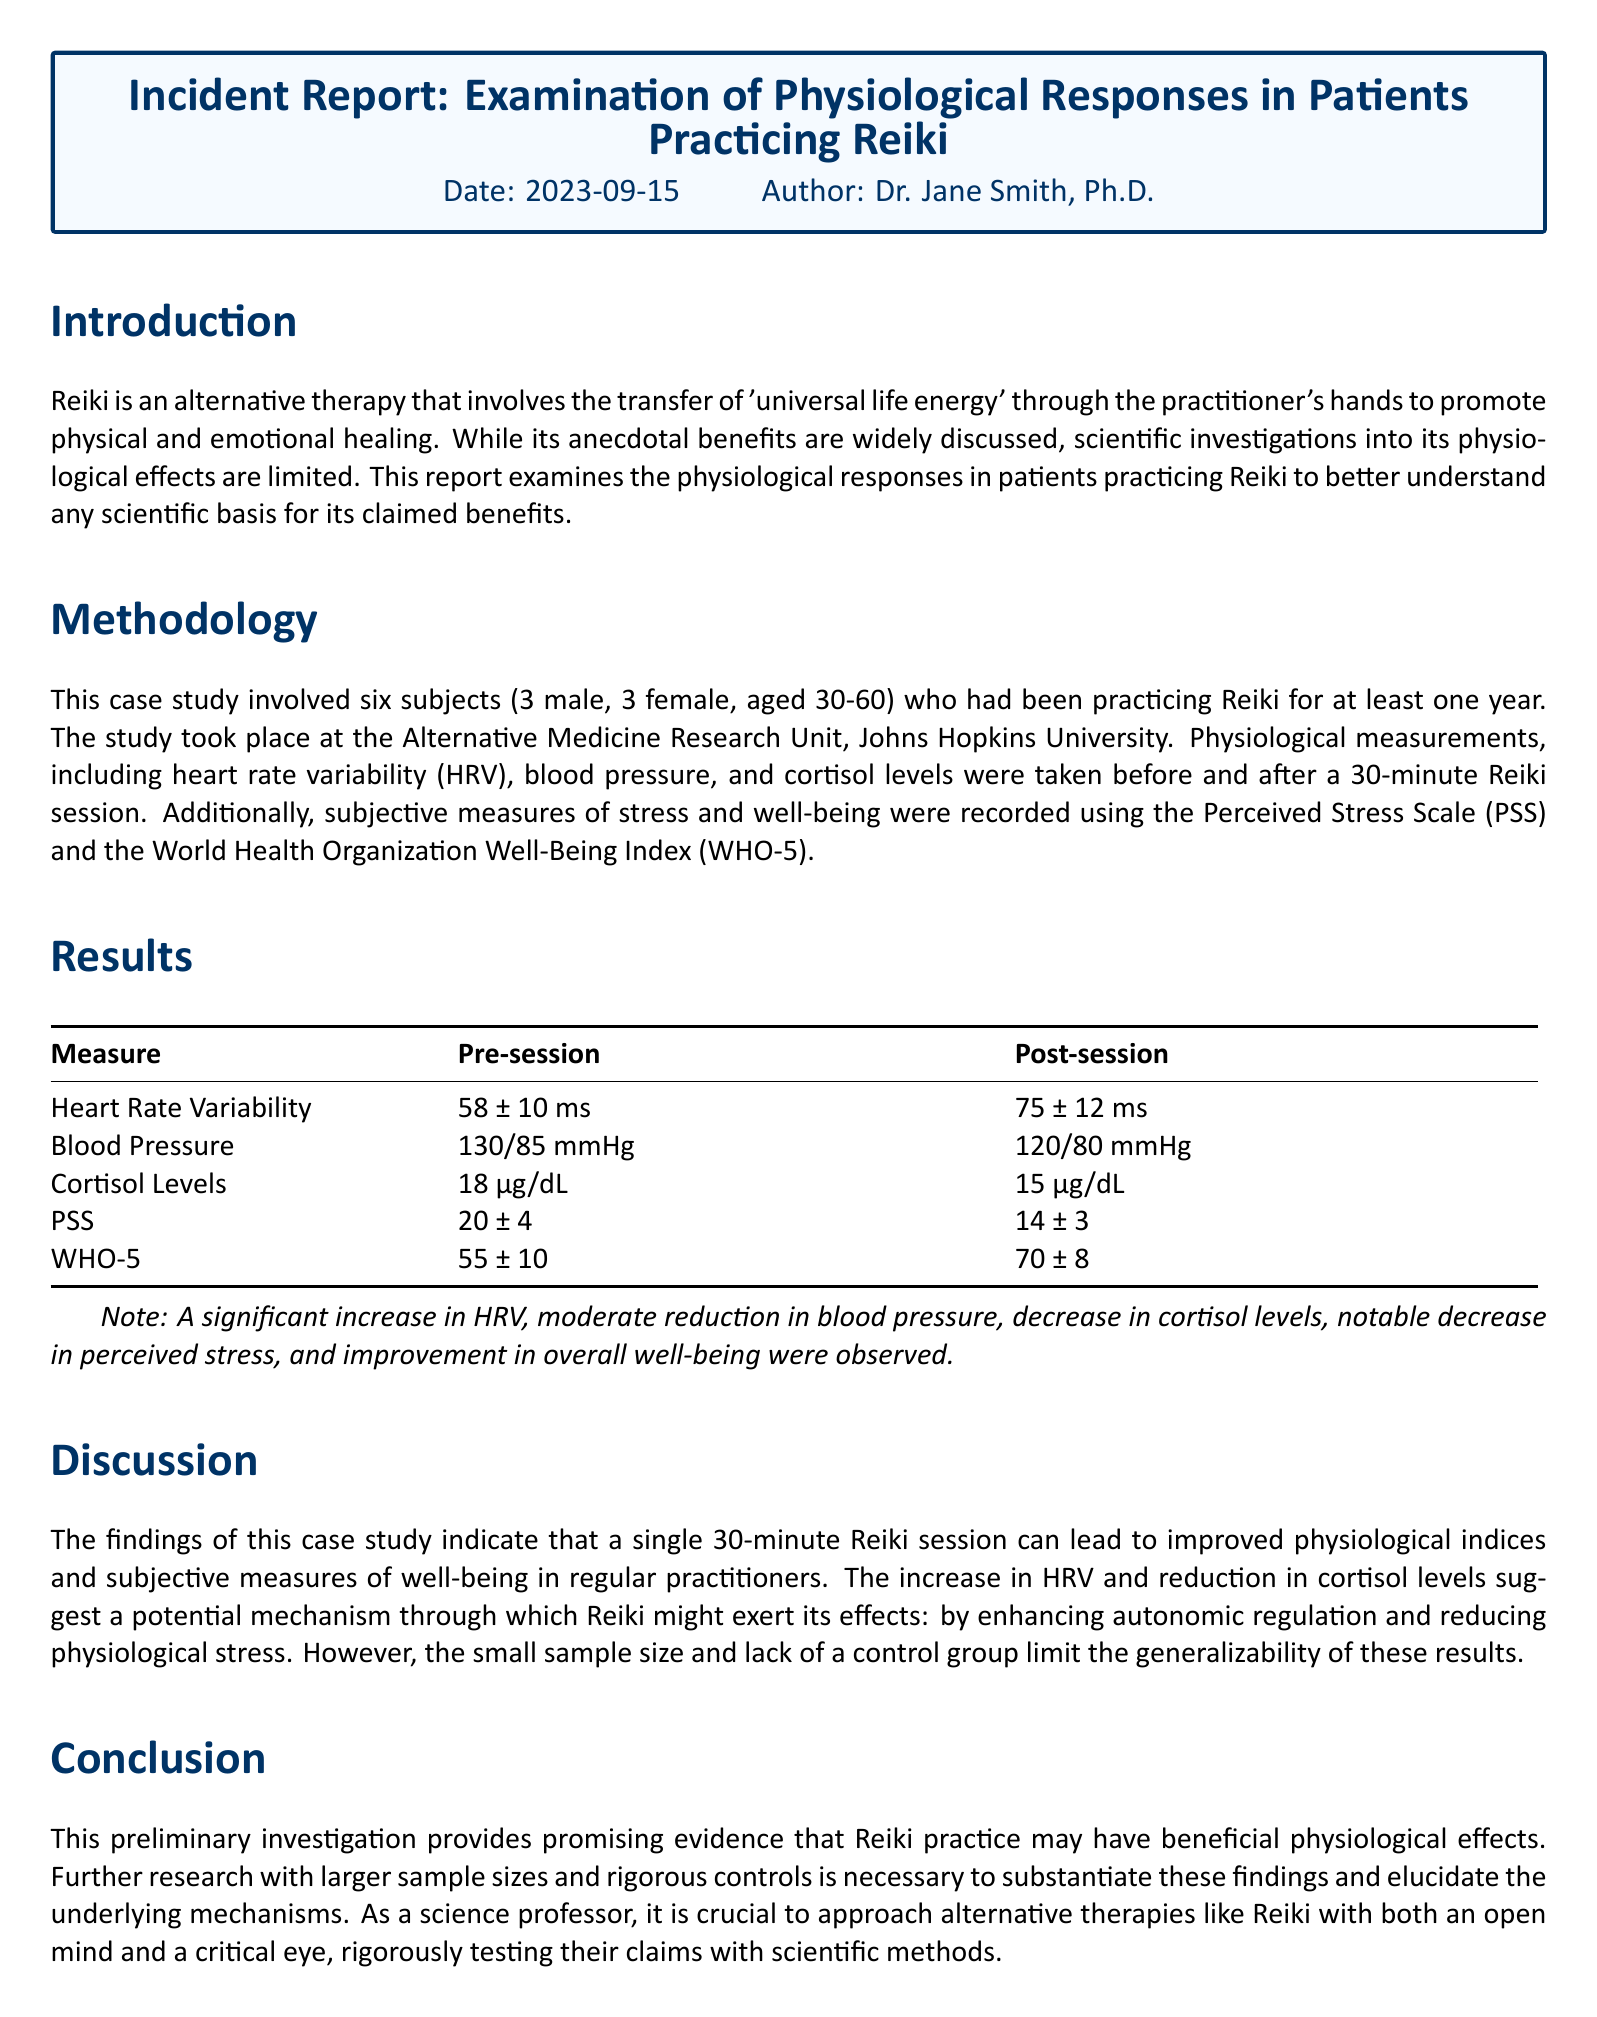What date was the report published? The date provided at the beginning of the report is when it was authored.
Answer: 2023-09-15 Who is the author of the incident report? The report lists the author's name right after the date in the header.
Answer: Dr. Jane Smith, Ph.D How many subjects were involved in the study? The methodology section specifies the number of subjects included in the investigation.
Answer: Six What physiological measure showed an increase post-session? The results table shows which measure improved after the Reiki session.
Answer: Heart Rate Variability What was the cortisol level before the Reiki session? The results table provides the pre-session value for cortisol levels.
Answer: 18 μg/dL What does PSS stand for? The methodology section mentions this abbreviation when referring to a specific scale used in the study.
Answer: Perceived Stress Scale What was the post-session score on the WHO-5 index? The results table indicates the score for this measure after the session.
Answer: 70 ± 8 What limitation is mentioned regarding the study? The discussion section addresses a concern affecting the findings' applicability.
Answer: Small sample size and lack of a control group What type of therapy does the report focus on? The introductory section defines the therapy being studied.
Answer: Reiki 